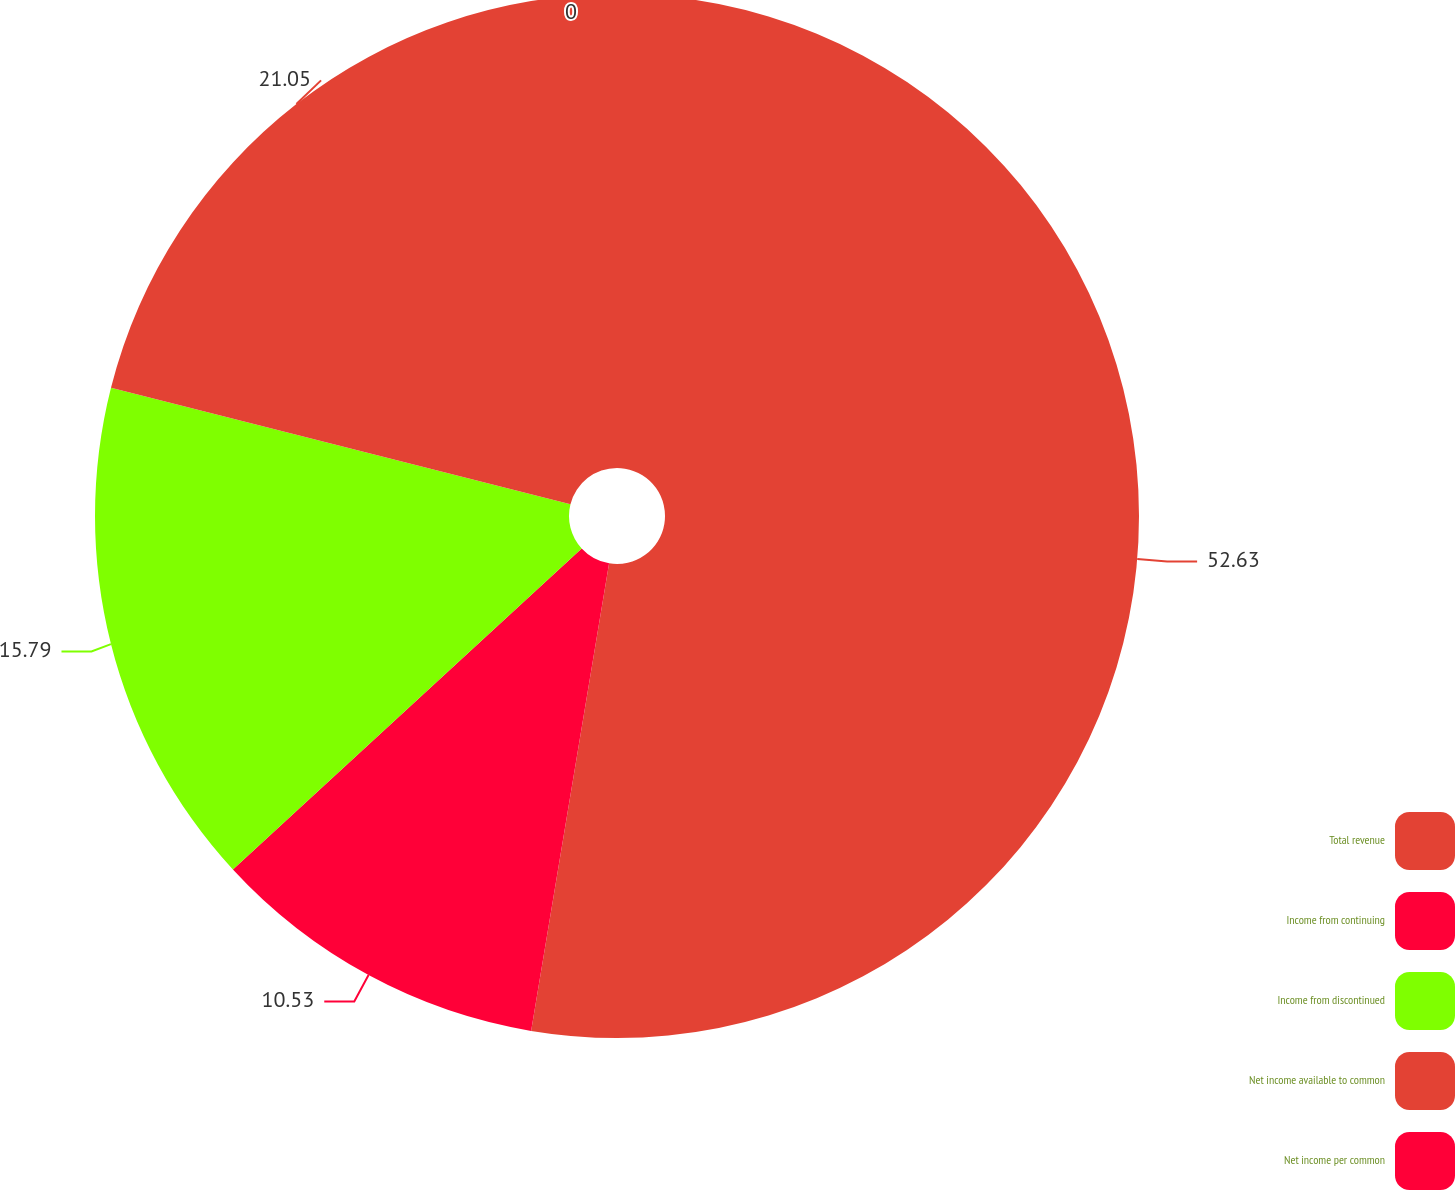Convert chart. <chart><loc_0><loc_0><loc_500><loc_500><pie_chart><fcel>Total revenue<fcel>Income from continuing<fcel>Income from discontinued<fcel>Net income available to common<fcel>Net income per common<nl><fcel>52.63%<fcel>10.53%<fcel>15.79%<fcel>21.05%<fcel>0.0%<nl></chart> 